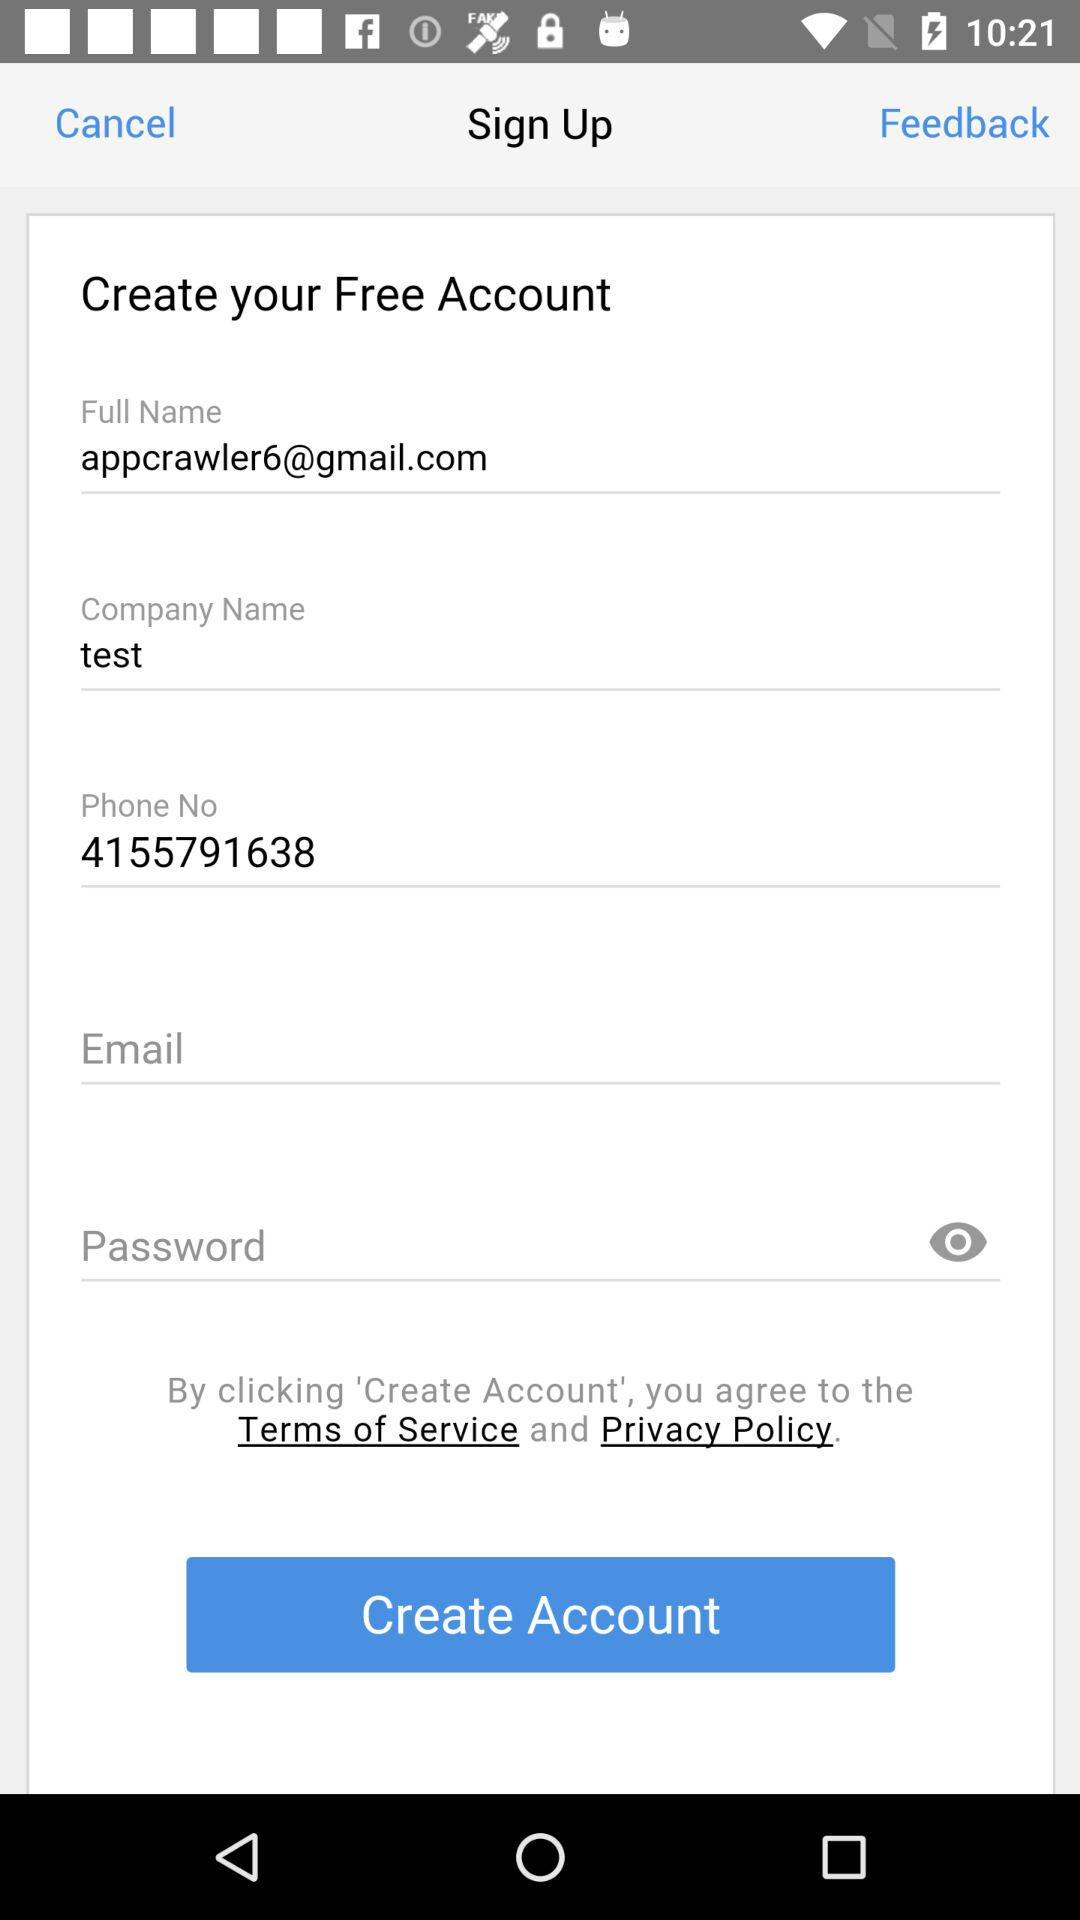What is the phone number? The phone number is 4155791638. 